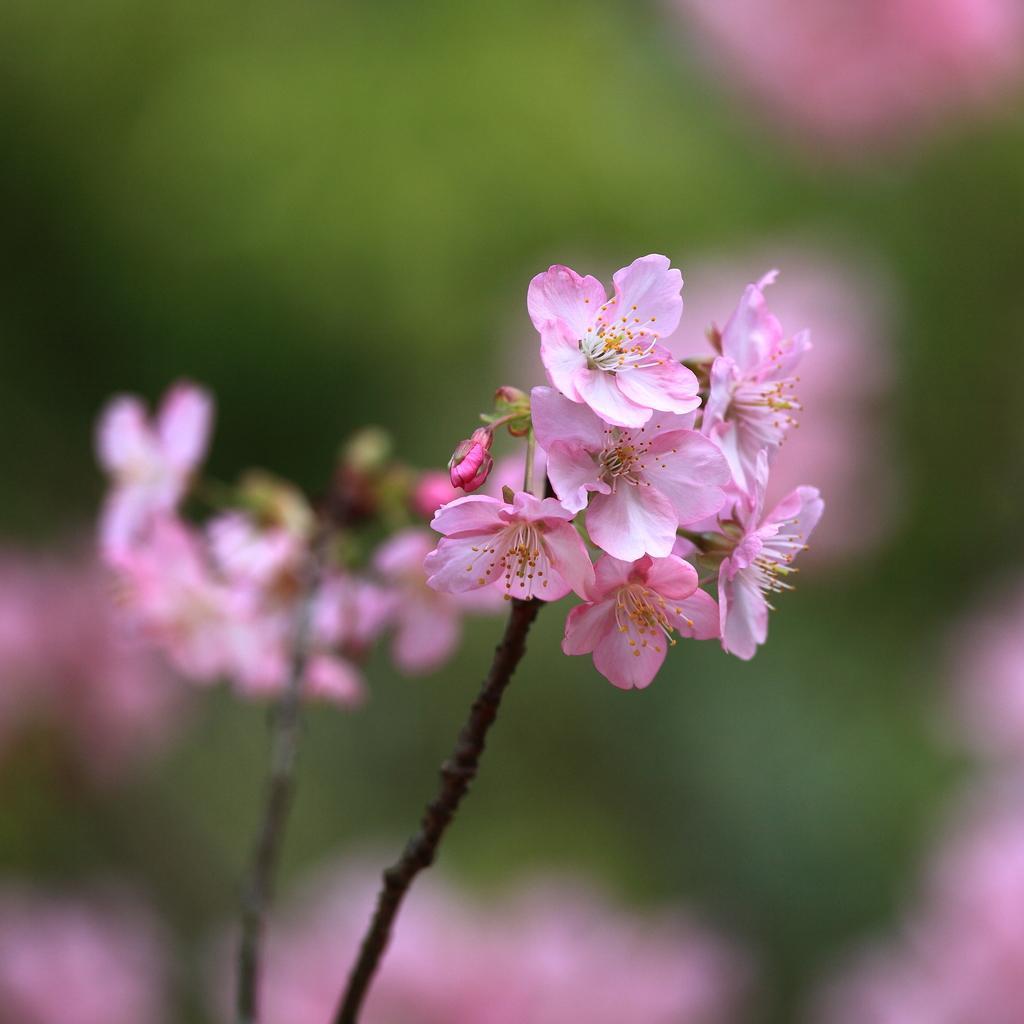Describe this image in one or two sentences. In the image there are pink color flowers on plant and the background is blurry. 